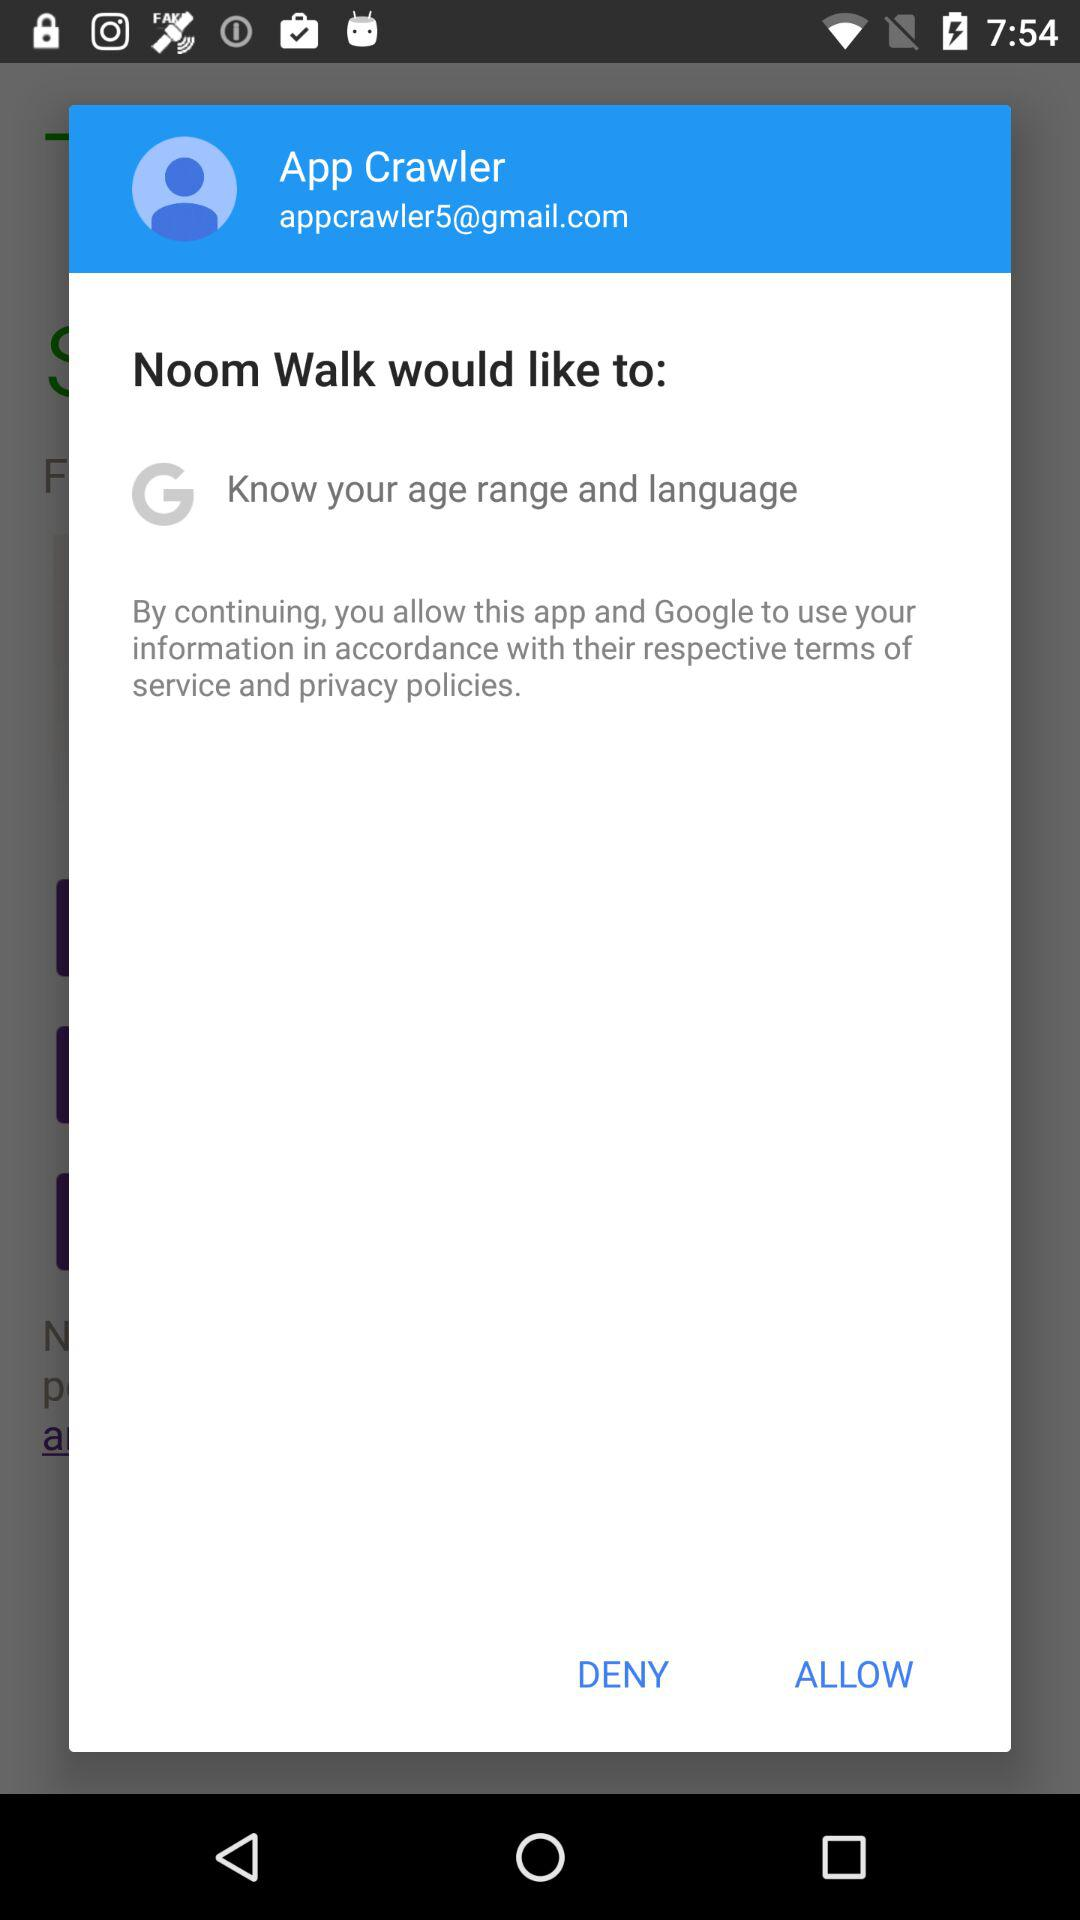What is the user name? The user name is App Crawler. 